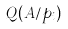Convert formula to latex. <formula><loc_0><loc_0><loc_500><loc_500>Q ( A / p _ { i } )</formula> 